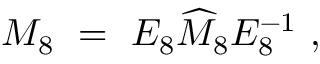Convert formula to latex. <formula><loc_0><loc_0><loc_500><loc_500>M _ { 8 } \ = \ E _ { 8 } \widehat { M } _ { 8 } E _ { 8 } ^ { - 1 } \ ,</formula> 